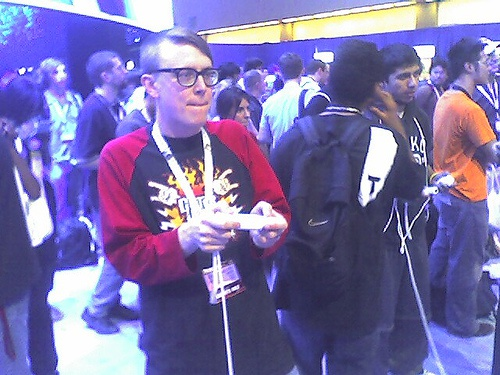Describe the objects in this image and their specific colors. I can see people in ivory, navy, white, and purple tones, people in ivory, navy, purple, blue, and white tones, people in ivory, blue, purple, salmon, and brown tones, backpack in ivory, navy, purple, and blue tones, and people in ivory, blue, violet, and darkblue tones in this image. 